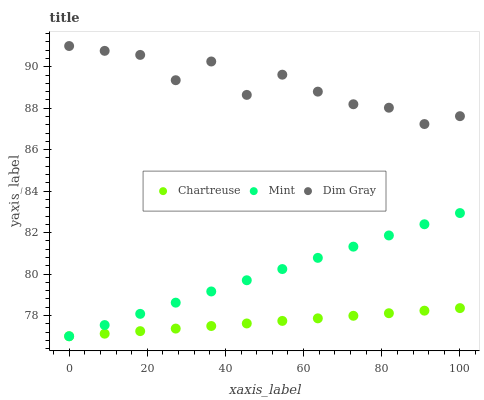Does Chartreuse have the minimum area under the curve?
Answer yes or no. Yes. Does Dim Gray have the maximum area under the curve?
Answer yes or no. Yes. Does Mint have the minimum area under the curve?
Answer yes or no. No. Does Mint have the maximum area under the curve?
Answer yes or no. No. Is Chartreuse the smoothest?
Answer yes or no. Yes. Is Dim Gray the roughest?
Answer yes or no. Yes. Is Mint the smoothest?
Answer yes or no. No. Is Mint the roughest?
Answer yes or no. No. Does Chartreuse have the lowest value?
Answer yes or no. Yes. Does Dim Gray have the lowest value?
Answer yes or no. No. Does Dim Gray have the highest value?
Answer yes or no. Yes. Does Mint have the highest value?
Answer yes or no. No. Is Mint less than Dim Gray?
Answer yes or no. Yes. Is Dim Gray greater than Chartreuse?
Answer yes or no. Yes. Does Mint intersect Chartreuse?
Answer yes or no. Yes. Is Mint less than Chartreuse?
Answer yes or no. No. Is Mint greater than Chartreuse?
Answer yes or no. No. Does Mint intersect Dim Gray?
Answer yes or no. No. 